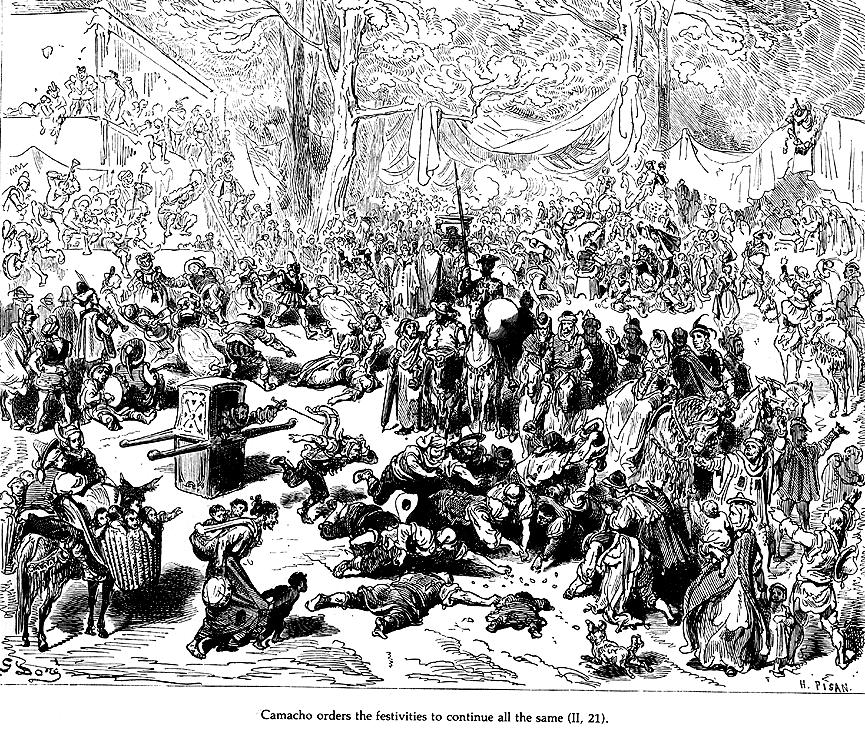What emotions do the central figures convey in this scene? The central figures in the scene, particularly around Camacho, express a range of emotions that underscore the dramatic nature of the event. Camacho himself appears authoritative and commanding, likely giving orders or directives. Adjacent to him, attendees show a mix of anticipation and eagerness, visible in their attentive postures and focused gazes. The overall atmosphere is vibrant and dynamic, reflecting the celebratory but controlled chaos of the festivities. This emotional depth adds a palpable tension and excitement to the scene, inviting viewers to wonder about the proceedings and the relationships between the characters. 